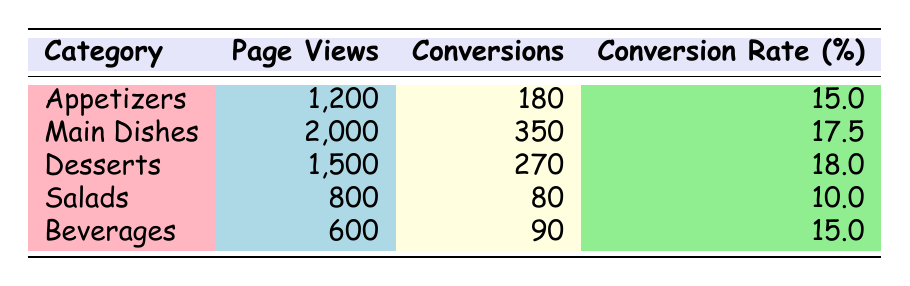What is the conversion rate for Desserts? The table displays a specific row for Desserts, which shows the Conversion Rate as 18.0%.
Answer: 18.0% Which category has the highest number of page views? Looking at the Page Views column, Main Dishes has the highest value of 2000.
Answer: Main Dishes How many total conversions are there across all categories? Adding the conversions: 180 + 350 + 270 + 80 + 90 = 970 in total.
Answer: 970 Is the conversion rate of Salads higher than that of Appetizers? Salads has a conversion rate of 10.0% and Appetizers has 15.0%. Since 10.0% is less than 15.0%, it's false.
Answer: No What is the average conversion rate for all categories? To find the average, sum up the conversion rates: (15.0 + 17.5 + 18.0 + 10.0 + 15.0) = 75.5, and divide by the number of categories (5), giving 75.5 / 5 = 15.1.
Answer: 15.1 Which category has the lowest conversion rate? By comparing the conversion rates, Salads has the lowest at 10.0%.
Answer: Salads If you combine the page views for Appetizers and Desserts, what do you get? Add the page views: 1200 (Appetizers) + 1500 (Desserts) = 2700 total page views.
Answer: 2700 Which category has the least number of conversions? By checking the Conversions column, Salads with 80 conversions is the lowest.
Answer: Salads What is the difference in conversion rates between Desserts and Main Dishes? Desserts has 18.0% and Main Dishes has 17.5%. The difference is 18.0% - 17.5% = 0.5%.
Answer: 0.5% 